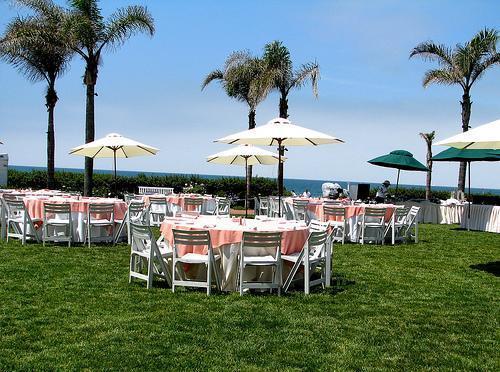How many white umbrellas are pictured?
Give a very brief answer. 4. How many blue umbrellas are in the scene?
Give a very brief answer. 2. How many palm trees are in the image?
Give a very brief answer. 5. How many set tables are visible?
Give a very brief answer. 4. How many people can seat at each table?
Give a very brief answer. 10. 